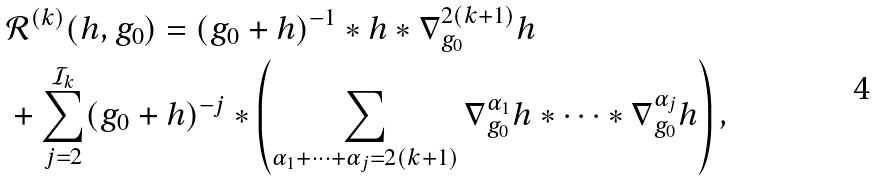<formula> <loc_0><loc_0><loc_500><loc_500>& \mathcal { R } ^ { ( k ) } ( h , g _ { 0 } ) = ( g _ { 0 } + h ) ^ { - 1 } * h * \nabla _ { g _ { 0 } } ^ { 2 ( k + 1 ) } h \\ & + \sum _ { j = 2 } ^ { \mathcal { I } _ { k } } ( g _ { 0 } + h ) ^ { - j } * \left ( \sum _ { \alpha _ { 1 } + \dots + \alpha _ { j } = 2 ( k + 1 ) } \nabla ^ { \alpha _ { 1 } } _ { g _ { 0 } } h * \dots * \nabla ^ { \alpha _ { j } } _ { g _ { 0 } } h \right ) ,</formula> 